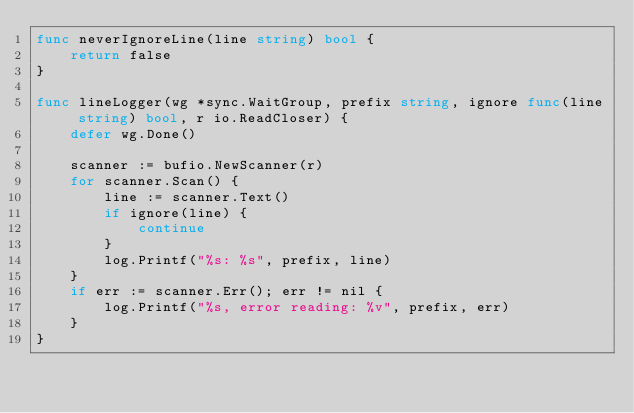Convert code to text. <code><loc_0><loc_0><loc_500><loc_500><_Go_>func neverIgnoreLine(line string) bool {
	return false
}

func lineLogger(wg *sync.WaitGroup, prefix string, ignore func(line string) bool, r io.ReadCloser) {
	defer wg.Done()

	scanner := bufio.NewScanner(r)
	for scanner.Scan() {
		line := scanner.Text()
		if ignore(line) {
			continue
		}
		log.Printf("%s: %s", prefix, line)
	}
	if err := scanner.Err(); err != nil {
		log.Printf("%s, error reading: %v", prefix, err)
	}
}
</code> 